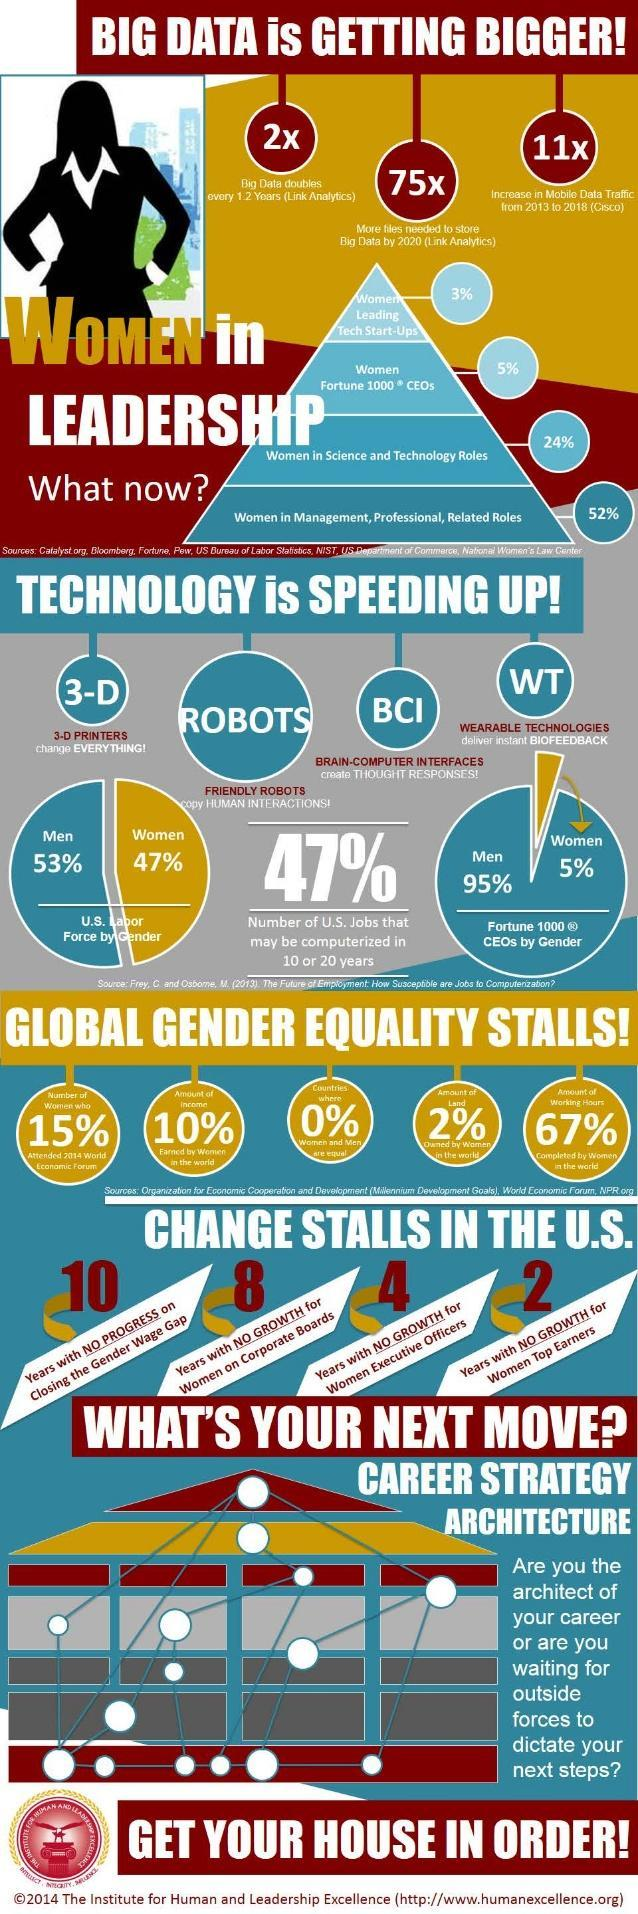What percent of the U.S. labor force are women?
Answer the question with a short phrase. 47% What percentage of the total income is earned by women in the world? 10% What percent of Fortune 1000 CEOs are women? 5% What percent of women are leading tech startups in the world? 3% What percent of the countries in the world treat both men & women as equals? 0% What percent of the U.S. labor force are men? 53% What percentage of land is owned by women in the world? 2% What percent of the women are employed in Science & Technology roles? 24% 